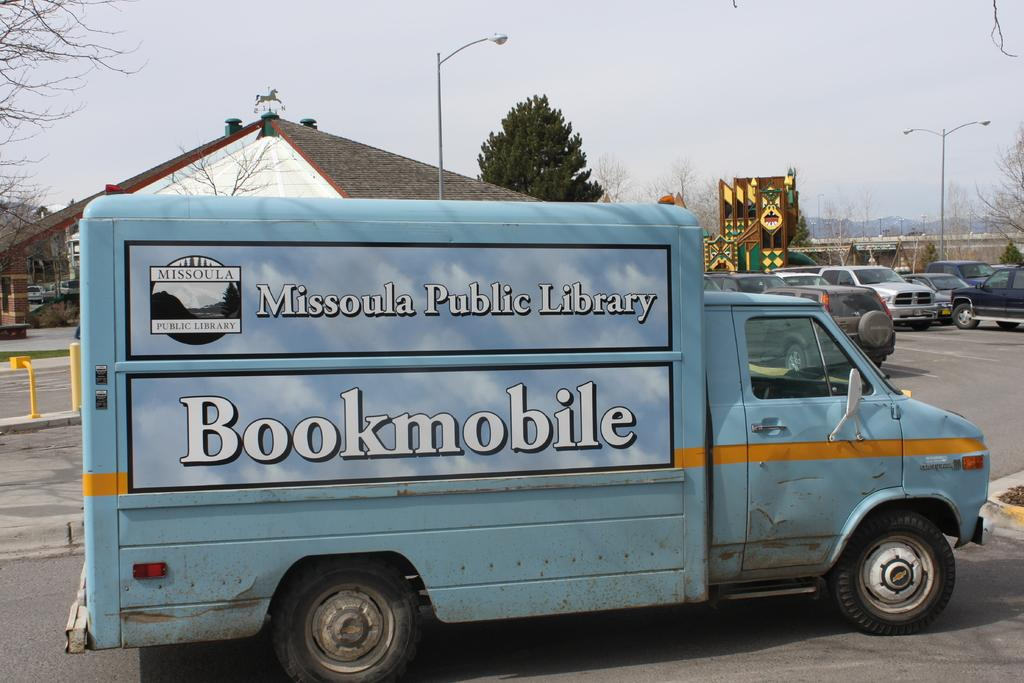What is happening on the road in the image? There are vehicles on the road in the image. What can be seen in the distance behind the vehicles? There is a house in the background of the image. What else is visible in the background of the image? Street lights are visible in the background of the image. How does the hill affect the nerve of the drivers in the image? There is no hill present in the image, and therefore no impact on the drivers' nerves can be observed. 